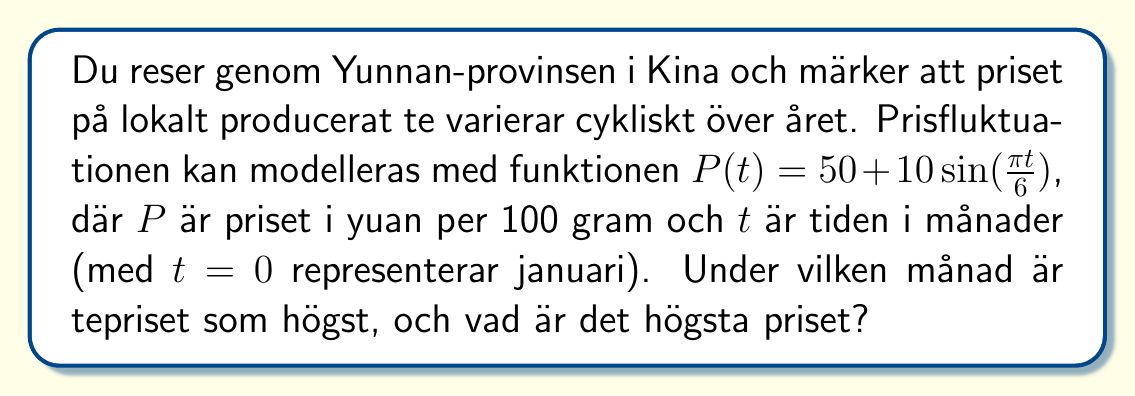Provide a solution to this math problem. 1) För att hitta den högsta priset, behöver vi hitta maximum av funktionen $P(t) = 50 + 10\sin(\frac{\pi t}{6})$.

2) Sinusfunktionen når sitt maximum när argumentet är $\frac{\pi}{2}$ eller $90°$. Så vi löser ekvationen:

   $\frac{\pi t}{6} = \frac{\pi}{2}$

3) Lös för $t$:
   $t = 6 \cdot \frac{1}{2} = 3$

4) Detta betyder att priset är högst när $t = 3$, vilket motsvarar april (eftersom $t = 0$ är januari).

5) För att hitta det högsta priset, sätt in $t = 3$ i originalfunktionen:

   $P(3) = 50 + 10\sin(\frac{\pi \cdot 3}{6}) = 50 + 10\sin(\frac{\pi}{2}) = 50 + 10 \cdot 1 = 60$

Därmed är det högsta priset 60 yuan per 100 gram.
Answer: April, 60 yuan 